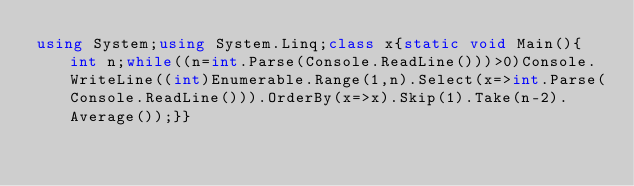Convert code to text. <code><loc_0><loc_0><loc_500><loc_500><_C#_>using System;using System.Linq;class x{static void Main(){int n;while((n=int.Parse(Console.ReadLine()))>0)Console.WriteLine((int)Enumerable.Range(1,n).Select(x=>int.Parse(Console.ReadLine())).OrderBy(x=>x).Skip(1).Take(n-2).Average());}}</code> 